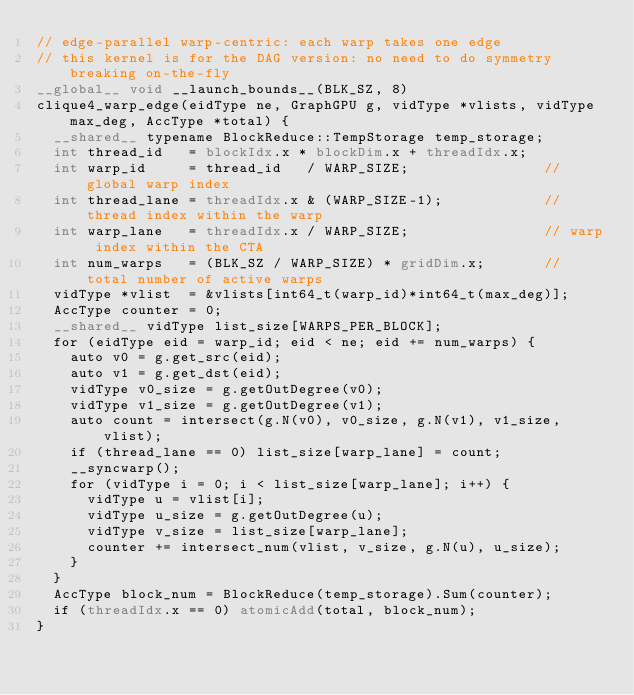Convert code to text. <code><loc_0><loc_0><loc_500><loc_500><_Cuda_>// edge-parallel warp-centric: each warp takes one edge
// this kernel is for the DAG version: no need to do symmetry breaking on-the-fly
__global__ void __launch_bounds__(BLK_SZ, 8)
clique4_warp_edge(eidType ne, GraphGPU g, vidType *vlists, vidType max_deg, AccType *total) {
  __shared__ typename BlockReduce::TempStorage temp_storage;
  int thread_id   = blockIdx.x * blockDim.x + threadIdx.x;
  int warp_id     = thread_id   / WARP_SIZE;                // global warp index
  int thread_lane = threadIdx.x & (WARP_SIZE-1);            // thread index within the warp
  int warp_lane   = threadIdx.x / WARP_SIZE;                // warp index within the CTA
  int num_warps   = (BLK_SZ / WARP_SIZE) * gridDim.x;       // total number of active warps
  vidType *vlist  = &vlists[int64_t(warp_id)*int64_t(max_deg)];
  AccType counter = 0;
  __shared__ vidType list_size[WARPS_PER_BLOCK];
  for (eidType eid = warp_id; eid < ne; eid += num_warps) {
    auto v0 = g.get_src(eid);
    auto v1 = g.get_dst(eid);
    vidType v0_size = g.getOutDegree(v0);
    vidType v1_size = g.getOutDegree(v1);
    auto count = intersect(g.N(v0), v0_size, g.N(v1), v1_size, vlist);
    if (thread_lane == 0) list_size[warp_lane] = count;
    __syncwarp();
    for (vidType i = 0; i < list_size[warp_lane]; i++) {
      vidType u = vlist[i];
      vidType u_size = g.getOutDegree(u);
      vidType v_size = list_size[warp_lane];
      counter += intersect_num(vlist, v_size, g.N(u), u_size);
    }
  }
  AccType block_num = BlockReduce(temp_storage).Sum(counter);
  if (threadIdx.x == 0) atomicAdd(total, block_num);
}

</code> 